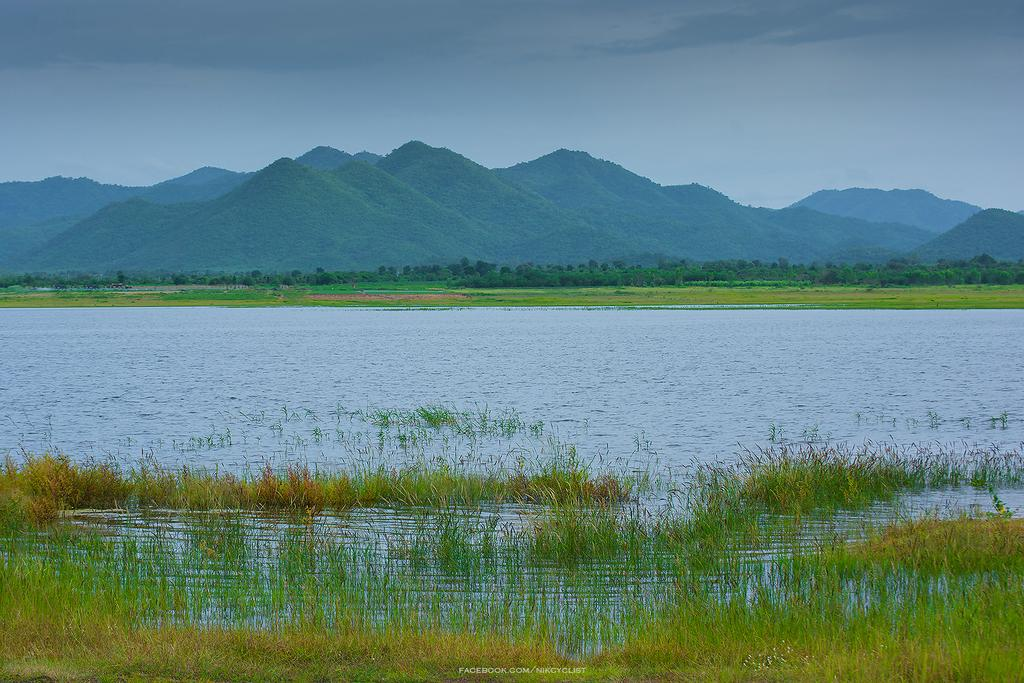What type of natural environment is depicted in the image? The image contains grass, water, plants, and hills, which are all elements of a natural environment. Can you describe the water in the image? The image shows water, but it doesn't provide specific details about its size or depth. What is visible in the sky in the image? The sky is visible in the image, but the facts don't mention any specific weather conditions or celestial bodies. What type of plants can be seen in the image? The image contains plants, but the facts don't specify their type or size. What type of stick can be seen in the bedroom in the image? There is no bedroom or stick present in the image; it depicts a natural environment with grass, water, plants, and hills. 